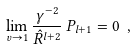<formula> <loc_0><loc_0><loc_500><loc_500>\lim _ { v \rightarrow 1 } \frac { \gamma ^ { - 2 } } { \hat { R } ^ { l + 2 } } \, P _ { l + 1 } = 0 \ ,</formula> 